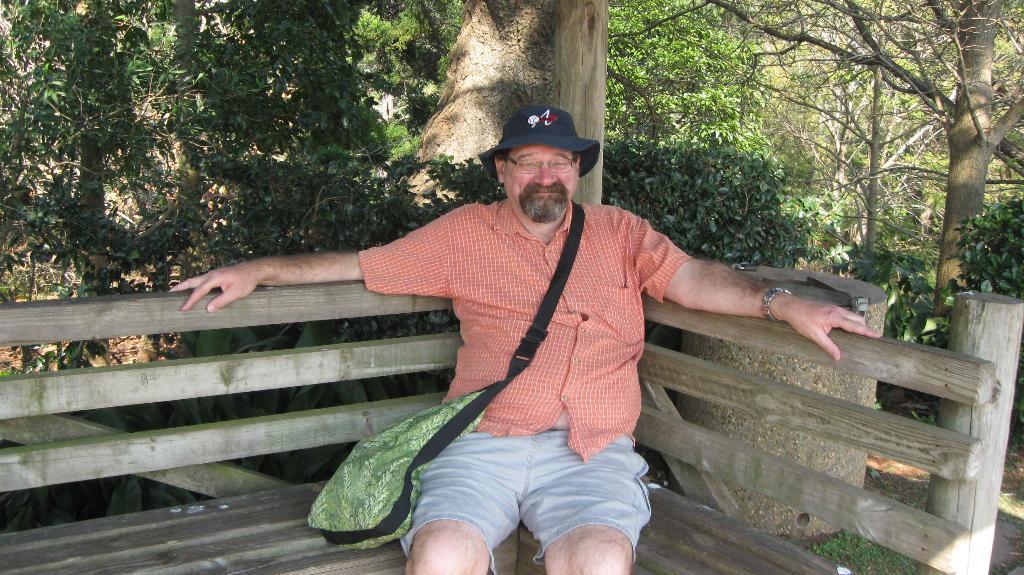Can you describe this image briefly? In this image, we can see a person is sitting on the bench and wearing bag and cap. He is watching and smiling. In the background, we can see plants, trees and cylindrical shape object. 